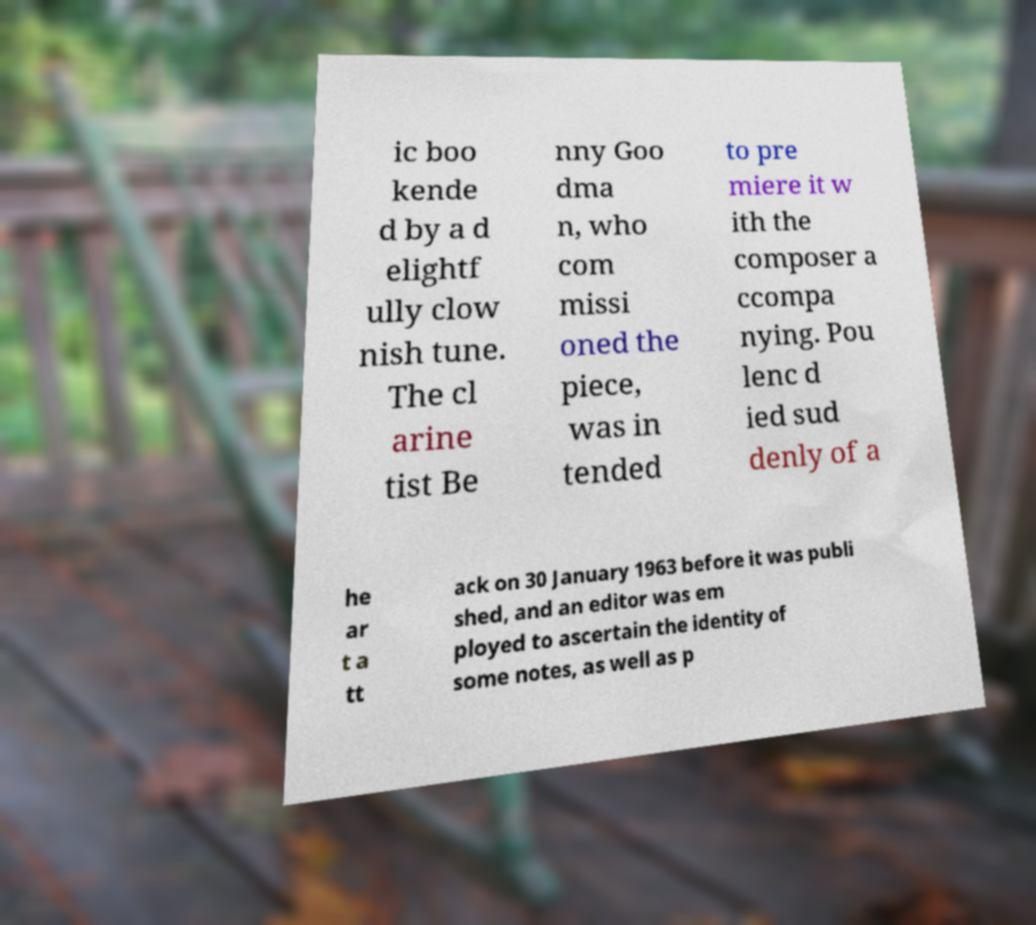There's text embedded in this image that I need extracted. Can you transcribe it verbatim? ic boo kende d by a d elightf ully clow nish tune. The cl arine tist Be nny Goo dma n, who com missi oned the piece, was in tended to pre miere it w ith the composer a ccompa nying. Pou lenc d ied sud denly of a he ar t a tt ack on 30 January 1963 before it was publi shed, and an editor was em ployed to ascertain the identity of some notes, as well as p 